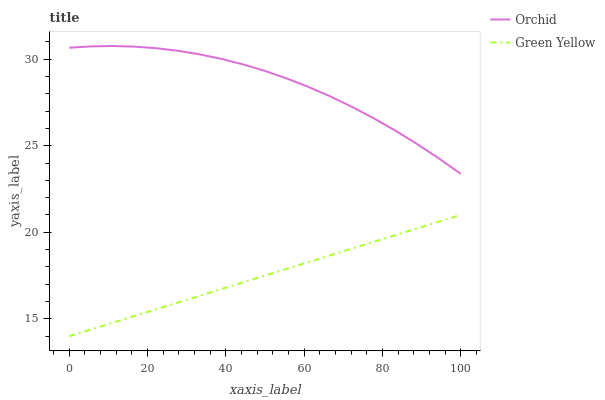Does Green Yellow have the minimum area under the curve?
Answer yes or no. Yes. Does Orchid have the maximum area under the curve?
Answer yes or no. Yes. Does Orchid have the minimum area under the curve?
Answer yes or no. No. Is Green Yellow the smoothest?
Answer yes or no. Yes. Is Orchid the roughest?
Answer yes or no. Yes. Is Orchid the smoothest?
Answer yes or no. No. Does Green Yellow have the lowest value?
Answer yes or no. Yes. Does Orchid have the lowest value?
Answer yes or no. No. Does Orchid have the highest value?
Answer yes or no. Yes. Is Green Yellow less than Orchid?
Answer yes or no. Yes. Is Orchid greater than Green Yellow?
Answer yes or no. Yes. Does Green Yellow intersect Orchid?
Answer yes or no. No. 